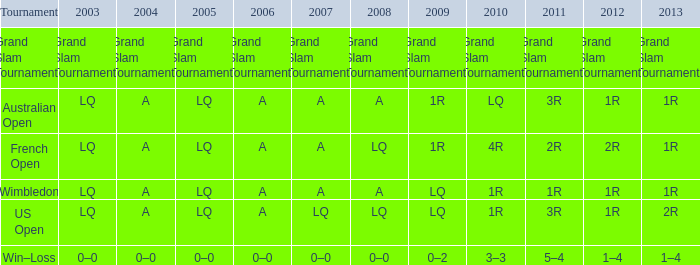Which year has a 2003 of lq? 1R, 1R, LQ, LQ. 